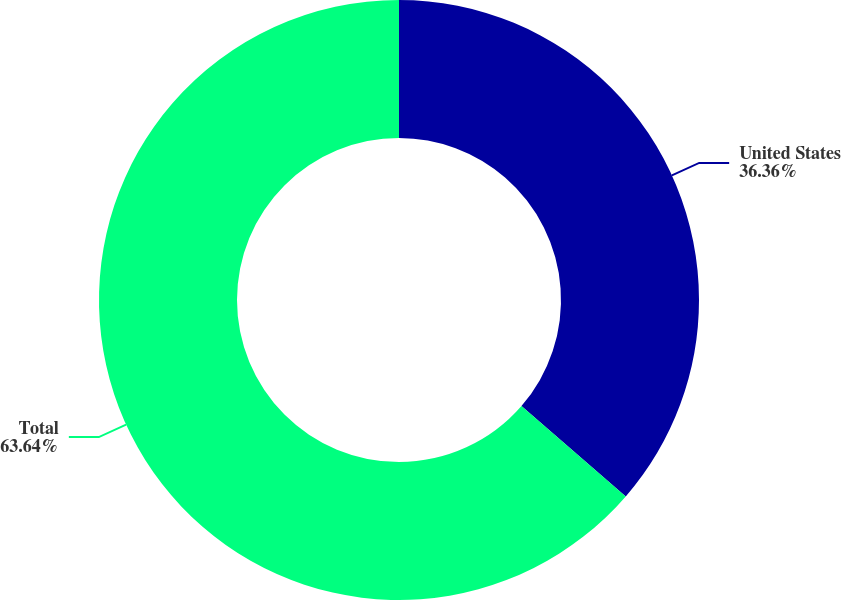<chart> <loc_0><loc_0><loc_500><loc_500><pie_chart><fcel>United States<fcel>Total<nl><fcel>36.36%<fcel>63.64%<nl></chart> 